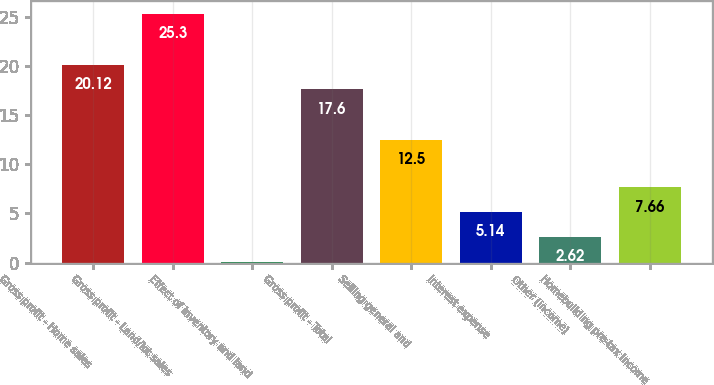Convert chart to OTSL. <chart><loc_0><loc_0><loc_500><loc_500><bar_chart><fcel>Gross profit - Home sales<fcel>Gross profit - Land/lot sales<fcel>Effect of inventory and land<fcel>Gross profit - Total<fcel>Selling general and<fcel>Interest expense<fcel>Other (income)<fcel>Homebuilding pre-tax income<nl><fcel>20.12<fcel>25.3<fcel>0.1<fcel>17.6<fcel>12.5<fcel>5.14<fcel>2.62<fcel>7.66<nl></chart> 